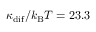<formula> <loc_0><loc_0><loc_500><loc_500>\kappa _ { d i f } / k _ { B } T = 2 3 . 3</formula> 